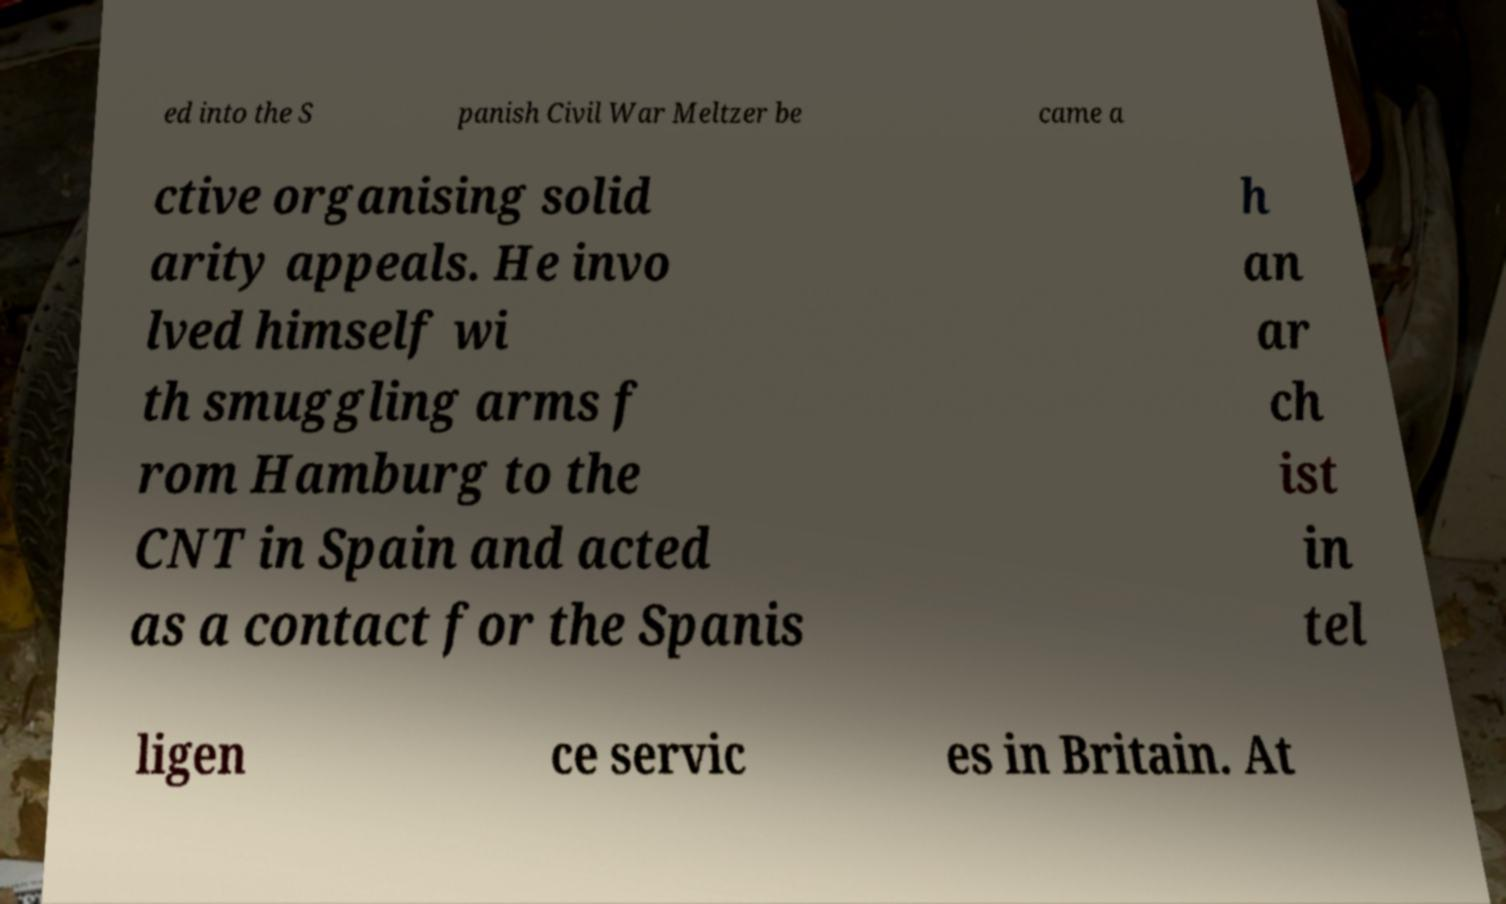Please identify and transcribe the text found in this image. ed into the S panish Civil War Meltzer be came a ctive organising solid arity appeals. He invo lved himself wi th smuggling arms f rom Hamburg to the CNT in Spain and acted as a contact for the Spanis h an ar ch ist in tel ligen ce servic es in Britain. At 